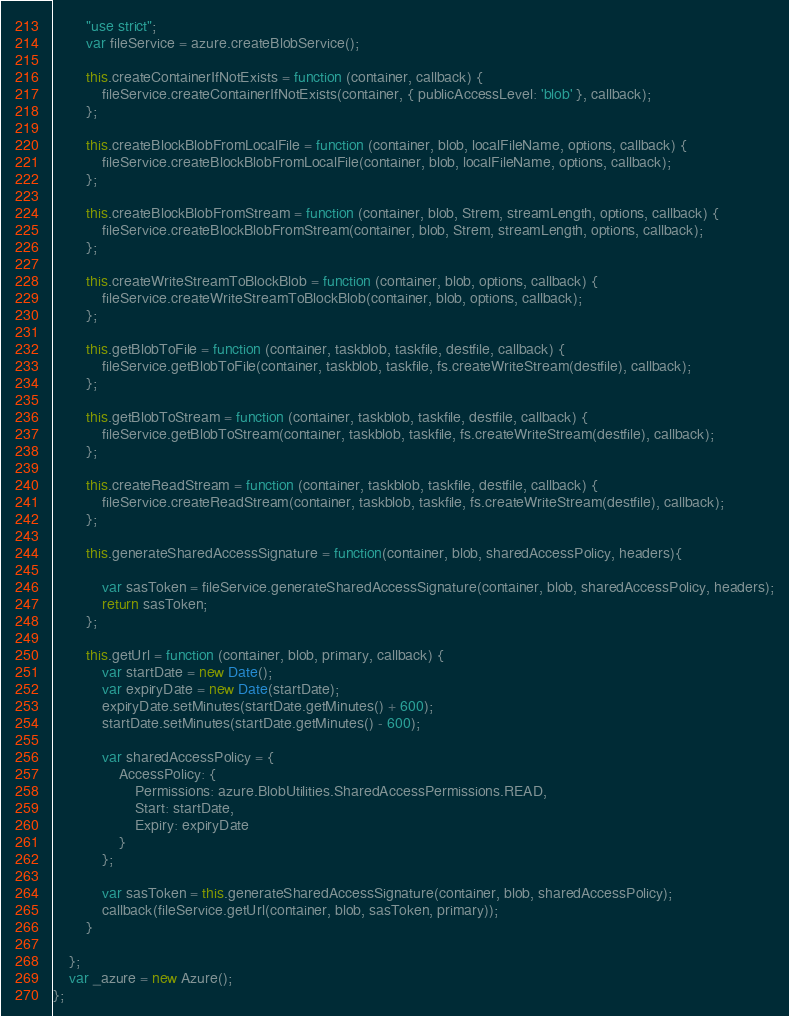<code> <loc_0><loc_0><loc_500><loc_500><_JavaScript_>        "use strict";
        var fileService = azure.createBlobService();

        this.createContainerIfNotExists = function (container, callback) {
            fileService.createContainerIfNotExists(container, { publicAccessLevel: 'blob' }, callback);
        };

        this.createBlockBlobFromLocalFile = function (container, blob, localFileName, options, callback) {
            fileService.createBlockBlobFromLocalFile(container, blob, localFileName, options, callback);
        };

        this.createBlockBlobFromStream = function (container, blob, Strem, streamLength, options, callback) {
            fileService.createBlockBlobFromStream(container, blob, Strem, streamLength, options, callback);
        };

        this.createWriteStreamToBlockBlob = function (container, blob, options, callback) {
            fileService.createWriteStreamToBlockBlob(container, blob, options, callback);
        };

        this.getBlobToFile = function (container, taskblob, taskfile, destfile, callback) {
            fileService.getBlobToFile(container, taskblob, taskfile, fs.createWriteStream(destfile), callback);
        };

        this.getBlobToStream = function (container, taskblob, taskfile, destfile, callback) {
            fileService.getBlobToStream(container, taskblob, taskfile, fs.createWriteStream(destfile), callback);
        };

        this.createReadStream = function (container, taskblob, taskfile, destfile, callback) {
            fileService.createReadStream(container, taskblob, taskfile, fs.createWriteStream(destfile), callback);
        };

        this.generateSharedAccessSignature = function(container, blob, sharedAccessPolicy, headers){

            var sasToken = fileService.generateSharedAccessSignature(container, blob, sharedAccessPolicy, headers);
            return sasToken;
        };

        this.getUrl = function (container, blob, primary, callback) {
            var startDate = new Date();
            var expiryDate = new Date(startDate);
            expiryDate.setMinutes(startDate.getMinutes() + 600);
            startDate.setMinutes(startDate.getMinutes() - 600);

            var sharedAccessPolicy = {
                AccessPolicy: {
                    Permissions: azure.BlobUtilities.SharedAccessPermissions.READ,
                    Start: startDate,
                    Expiry: expiryDate
                }
            };

            var sasToken = this.generateSharedAccessSignature(container, blob, sharedAccessPolicy);
            callback(fileService.getUrl(container, blob, sasToken, primary));
        }

    };
    var _azure = new Azure();
};
</code> 